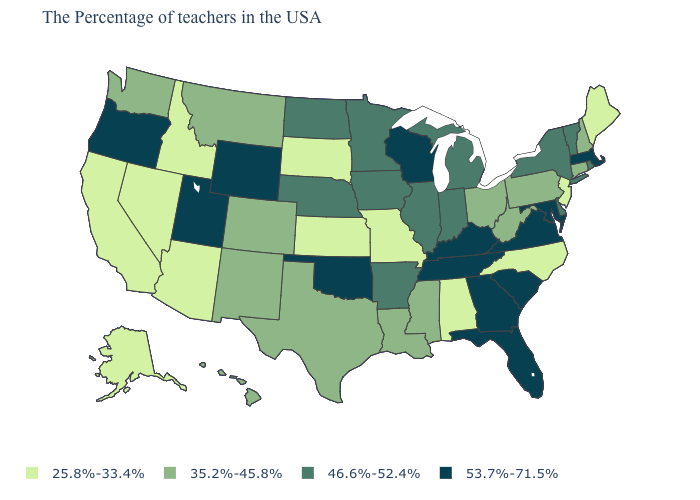Name the states that have a value in the range 35.2%-45.8%?
Be succinct. New Hampshire, Connecticut, Pennsylvania, West Virginia, Ohio, Mississippi, Louisiana, Texas, Colorado, New Mexico, Montana, Washington, Hawaii. What is the lowest value in the USA?
Answer briefly. 25.8%-33.4%. Among the states that border Tennessee , which have the highest value?
Concise answer only. Virginia, Georgia, Kentucky. What is the value of Vermont?
Answer briefly. 46.6%-52.4%. Does North Dakota have a lower value than Oregon?
Short answer required. Yes. Name the states that have a value in the range 53.7%-71.5%?
Concise answer only. Massachusetts, Maryland, Virginia, South Carolina, Florida, Georgia, Kentucky, Tennessee, Wisconsin, Oklahoma, Wyoming, Utah, Oregon. What is the lowest value in the USA?
Answer briefly. 25.8%-33.4%. Is the legend a continuous bar?
Answer briefly. No. Name the states that have a value in the range 53.7%-71.5%?
Give a very brief answer. Massachusetts, Maryland, Virginia, South Carolina, Florida, Georgia, Kentucky, Tennessee, Wisconsin, Oklahoma, Wyoming, Utah, Oregon. Among the states that border Kentucky , which have the lowest value?
Be succinct. Missouri. Among the states that border Louisiana , does Arkansas have the lowest value?
Be succinct. No. What is the value of Kentucky?
Write a very short answer. 53.7%-71.5%. Name the states that have a value in the range 25.8%-33.4%?
Answer briefly. Maine, New Jersey, North Carolina, Alabama, Missouri, Kansas, South Dakota, Arizona, Idaho, Nevada, California, Alaska. Does Kansas have the same value as Indiana?
Be succinct. No. Name the states that have a value in the range 25.8%-33.4%?
Give a very brief answer. Maine, New Jersey, North Carolina, Alabama, Missouri, Kansas, South Dakota, Arizona, Idaho, Nevada, California, Alaska. 